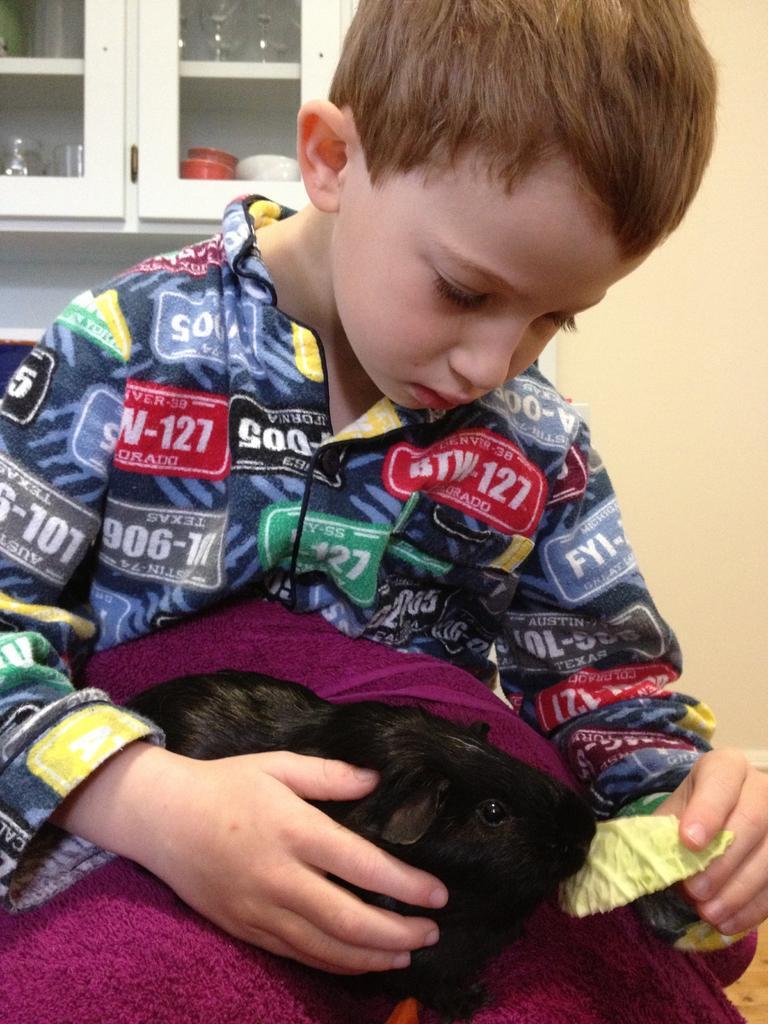Could you give a brief overview of what you see in this image? In this picture there is a small boy in the center of the image and there is a puppy at the bottom side of the image, the boy is feeding it and there are cupboards at the top side of the image. 